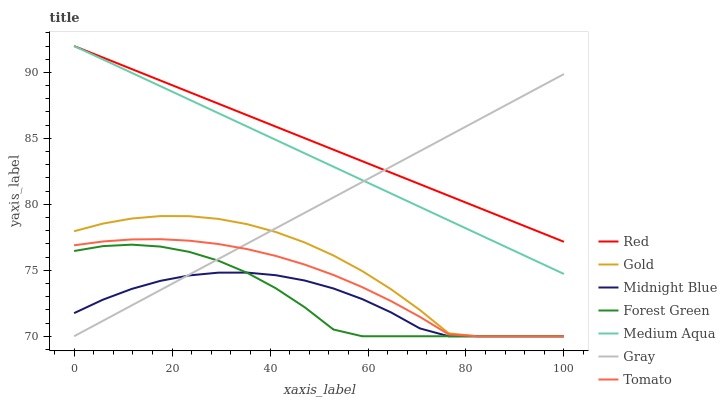Does Midnight Blue have the minimum area under the curve?
Answer yes or no. Yes. Does Red have the maximum area under the curve?
Answer yes or no. Yes. Does Gray have the minimum area under the curve?
Answer yes or no. No. Does Gray have the maximum area under the curve?
Answer yes or no. No. Is Red the smoothest?
Answer yes or no. Yes. Is Gold the roughest?
Answer yes or no. Yes. Is Gray the smoothest?
Answer yes or no. No. Is Gray the roughest?
Answer yes or no. No. Does Medium Aqua have the lowest value?
Answer yes or no. No. Does Gray have the highest value?
Answer yes or no. No. Is Midnight Blue less than Red?
Answer yes or no. Yes. Is Red greater than Gold?
Answer yes or no. Yes. Does Midnight Blue intersect Red?
Answer yes or no. No. 